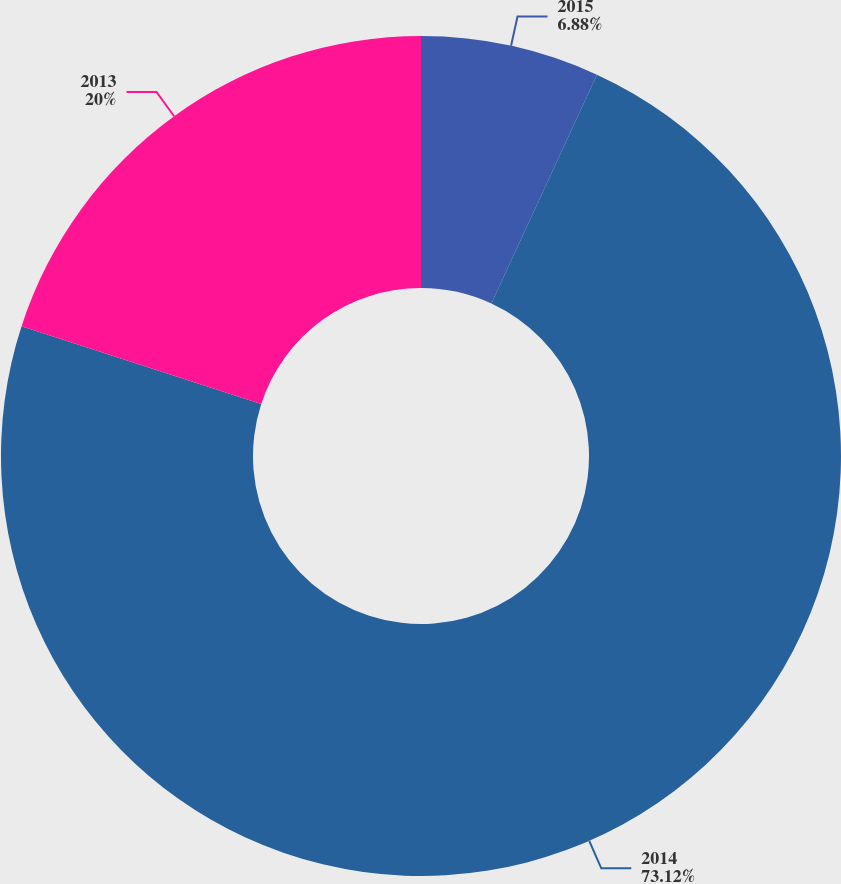Convert chart. <chart><loc_0><loc_0><loc_500><loc_500><pie_chart><fcel>2015<fcel>2014<fcel>2013<nl><fcel>6.88%<fcel>73.12%<fcel>20.0%<nl></chart> 